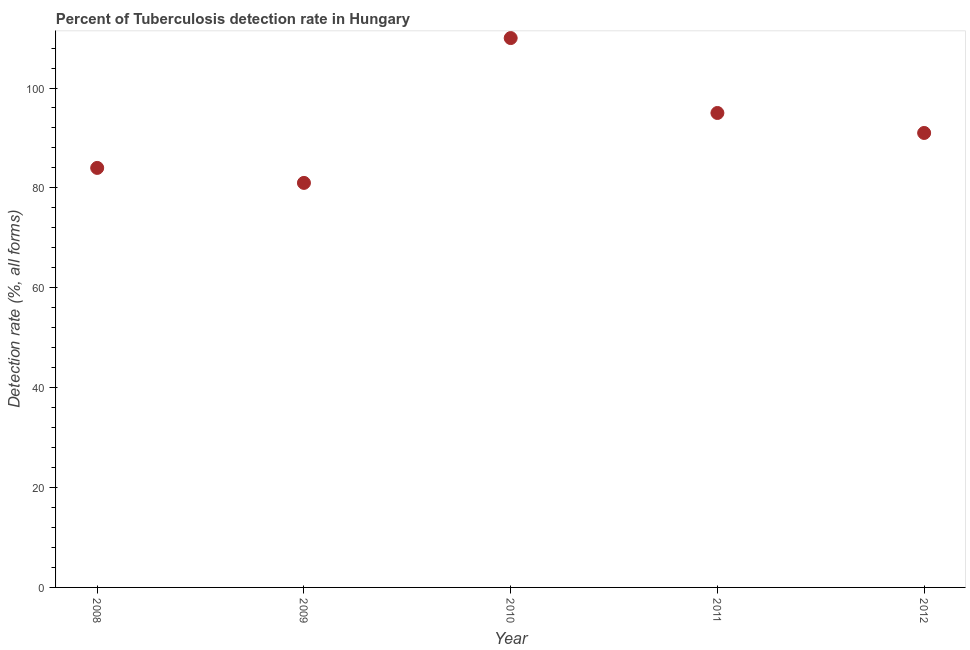What is the detection rate of tuberculosis in 2011?
Your answer should be very brief. 95. Across all years, what is the maximum detection rate of tuberculosis?
Offer a terse response. 110. Across all years, what is the minimum detection rate of tuberculosis?
Offer a very short reply. 81. In which year was the detection rate of tuberculosis minimum?
Your answer should be compact. 2009. What is the sum of the detection rate of tuberculosis?
Offer a terse response. 461. What is the difference between the detection rate of tuberculosis in 2011 and 2012?
Offer a very short reply. 4. What is the average detection rate of tuberculosis per year?
Your answer should be very brief. 92.2. What is the median detection rate of tuberculosis?
Make the answer very short. 91. Do a majority of the years between 2009 and 2012 (inclusive) have detection rate of tuberculosis greater than 24 %?
Provide a short and direct response. Yes. What is the ratio of the detection rate of tuberculosis in 2008 to that in 2009?
Give a very brief answer. 1.04. Is the difference between the detection rate of tuberculosis in 2010 and 2011 greater than the difference between any two years?
Keep it short and to the point. No. Is the sum of the detection rate of tuberculosis in 2008 and 2011 greater than the maximum detection rate of tuberculosis across all years?
Your response must be concise. Yes. What is the difference between the highest and the lowest detection rate of tuberculosis?
Give a very brief answer. 29. What is the difference between two consecutive major ticks on the Y-axis?
Give a very brief answer. 20. Does the graph contain any zero values?
Your answer should be very brief. No. What is the title of the graph?
Make the answer very short. Percent of Tuberculosis detection rate in Hungary. What is the label or title of the Y-axis?
Offer a terse response. Detection rate (%, all forms). What is the Detection rate (%, all forms) in 2008?
Keep it short and to the point. 84. What is the Detection rate (%, all forms) in 2009?
Offer a very short reply. 81. What is the Detection rate (%, all forms) in 2010?
Keep it short and to the point. 110. What is the Detection rate (%, all forms) in 2012?
Offer a very short reply. 91. What is the difference between the Detection rate (%, all forms) in 2008 and 2010?
Offer a very short reply. -26. What is the difference between the Detection rate (%, all forms) in 2008 and 2011?
Give a very brief answer. -11. What is the difference between the Detection rate (%, all forms) in 2008 and 2012?
Make the answer very short. -7. What is the difference between the Detection rate (%, all forms) in 2009 and 2011?
Your response must be concise. -14. What is the difference between the Detection rate (%, all forms) in 2010 and 2011?
Provide a short and direct response. 15. What is the ratio of the Detection rate (%, all forms) in 2008 to that in 2010?
Offer a very short reply. 0.76. What is the ratio of the Detection rate (%, all forms) in 2008 to that in 2011?
Give a very brief answer. 0.88. What is the ratio of the Detection rate (%, all forms) in 2008 to that in 2012?
Make the answer very short. 0.92. What is the ratio of the Detection rate (%, all forms) in 2009 to that in 2010?
Make the answer very short. 0.74. What is the ratio of the Detection rate (%, all forms) in 2009 to that in 2011?
Offer a terse response. 0.85. What is the ratio of the Detection rate (%, all forms) in 2009 to that in 2012?
Ensure brevity in your answer.  0.89. What is the ratio of the Detection rate (%, all forms) in 2010 to that in 2011?
Your response must be concise. 1.16. What is the ratio of the Detection rate (%, all forms) in 2010 to that in 2012?
Make the answer very short. 1.21. What is the ratio of the Detection rate (%, all forms) in 2011 to that in 2012?
Keep it short and to the point. 1.04. 